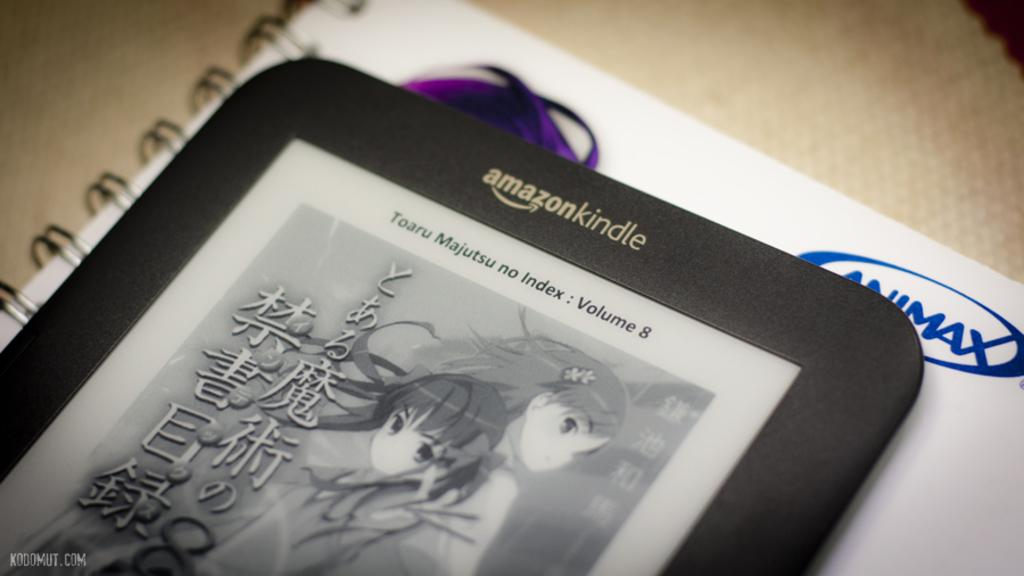<image>
Relay a brief, clear account of the picture shown. an Amazon kindle is on the white paper 